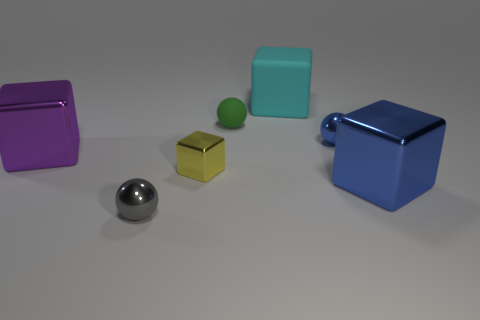Does the small thing on the right side of the large cyan rubber thing have the same shape as the rubber thing left of the large matte object?
Ensure brevity in your answer.  Yes. What size is the thing that is in front of the tiny blue sphere and on the right side of the large cyan rubber thing?
Offer a very short reply. Large. What number of other things are there of the same color as the tiny matte object?
Keep it short and to the point. 0. Does the small object that is to the left of the yellow object have the same material as the purple block?
Offer a very short reply. Yes. Are there fewer tiny cubes that are to the left of the large cyan matte block than yellow shiny cubes that are behind the gray shiny object?
Provide a succinct answer. No. What number of blue things are in front of the big metal cube left of the blue thing right of the small blue metal thing?
Make the answer very short. 1. There is a small yellow metal cube; what number of cubes are behind it?
Provide a short and direct response. 2. What number of blue balls have the same material as the green ball?
Provide a succinct answer. 0. What color is the other large object that is the same material as the purple thing?
Ensure brevity in your answer.  Blue. The big cyan block that is behind the metallic thing that is in front of the big object on the right side of the blue ball is made of what material?
Offer a very short reply. Rubber. 